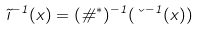Convert formula to latex. <formula><loc_0><loc_0><loc_500><loc_500>\tilde { \zeta } ^ { - 1 } ( x ) = ( \vartheta ^ { \ast } ) ^ { - 1 } ( \kappa ^ { - 1 } ( x ) )</formula> 